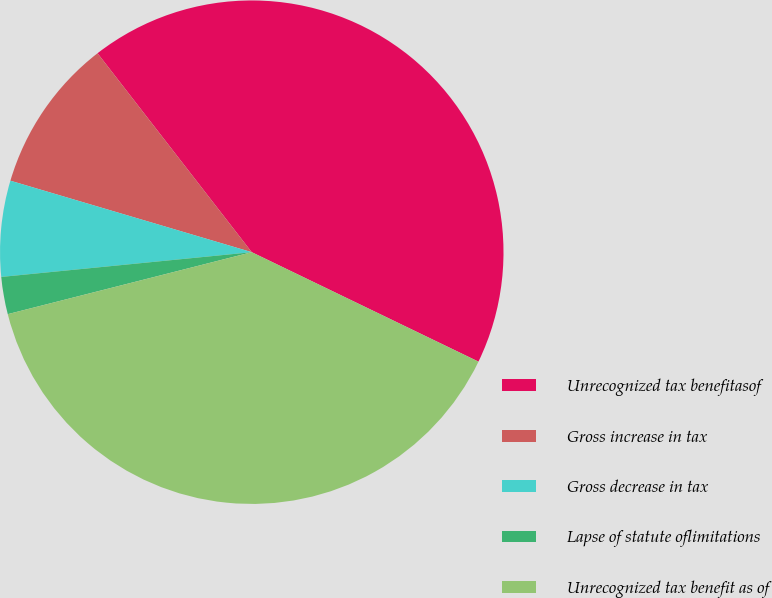Convert chart. <chart><loc_0><loc_0><loc_500><loc_500><pie_chart><fcel>Unrecognized tax benefitasof<fcel>Gross increase in tax<fcel>Gross decrease in tax<fcel>Lapse of statute oflimitations<fcel>Unrecognized tax benefit as of<nl><fcel>42.65%<fcel>9.92%<fcel>6.15%<fcel>2.39%<fcel>38.88%<nl></chart> 